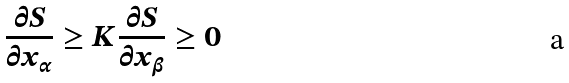Convert formula to latex. <formula><loc_0><loc_0><loc_500><loc_500>\frac { \partial S } { \partial x _ { \alpha } } \geq K \frac { \partial S } { \partial x _ { \beta } } \geq 0</formula> 